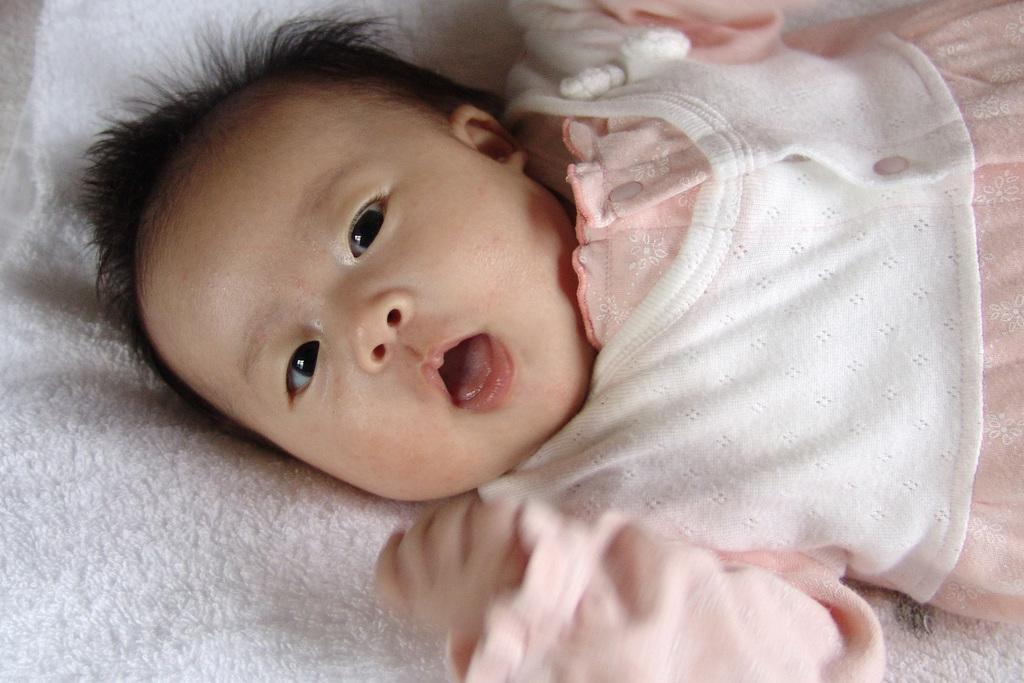What is the main subject of the image? The main subject of the image is an infant. What is the infant lying on? The infant is lying on a white object. Is the infant playing baseball in the image? No, the infant is not playing baseball in the image. Is there any water visible in the image? There is no mention of water in the provided facts, so we cannot determine if it is present in the image. 